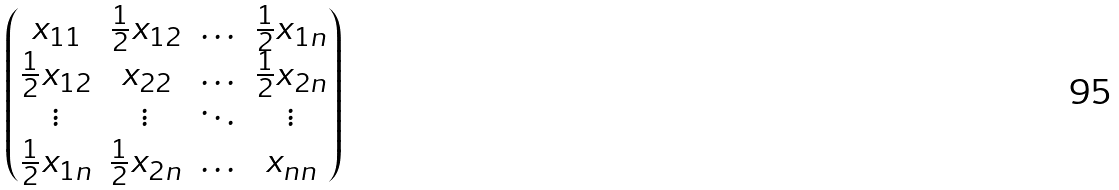<formula> <loc_0><loc_0><loc_500><loc_500>\begin{pmatrix} x _ { 1 1 } & { \frac { 1 } { 2 } } x _ { 1 2 } & \hdots & { \frac { 1 } { 2 } } x _ { 1 n } \\ { \frac { 1 } { 2 } } x _ { 1 2 } & x _ { 2 2 } & \hdots & { \frac { 1 } { 2 } } x _ { 2 n } \\ \vdots & \vdots & \ddots & \vdots \\ { \frac { 1 } { 2 } } x _ { 1 n } & { \frac { 1 } { 2 } } x _ { 2 n } & \hdots & x _ { n n } \end{pmatrix}</formula> 